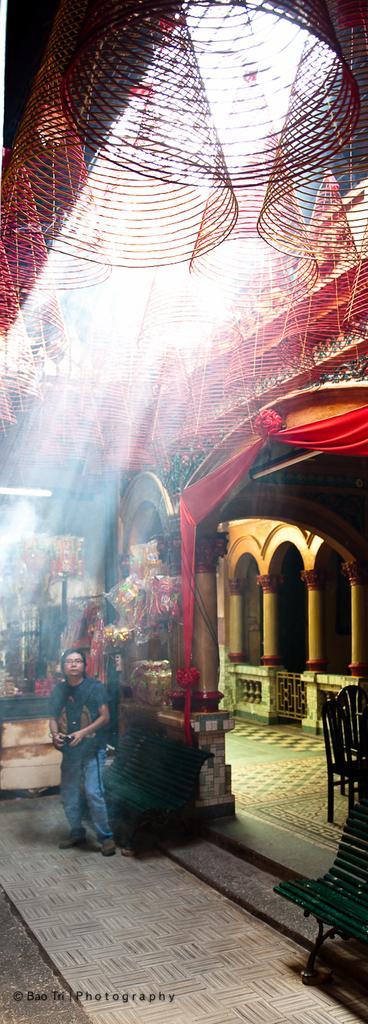Can you describe this image briefly? In this image one room is there some person is standing in the room in room there are some flowers there and background is sunny. 